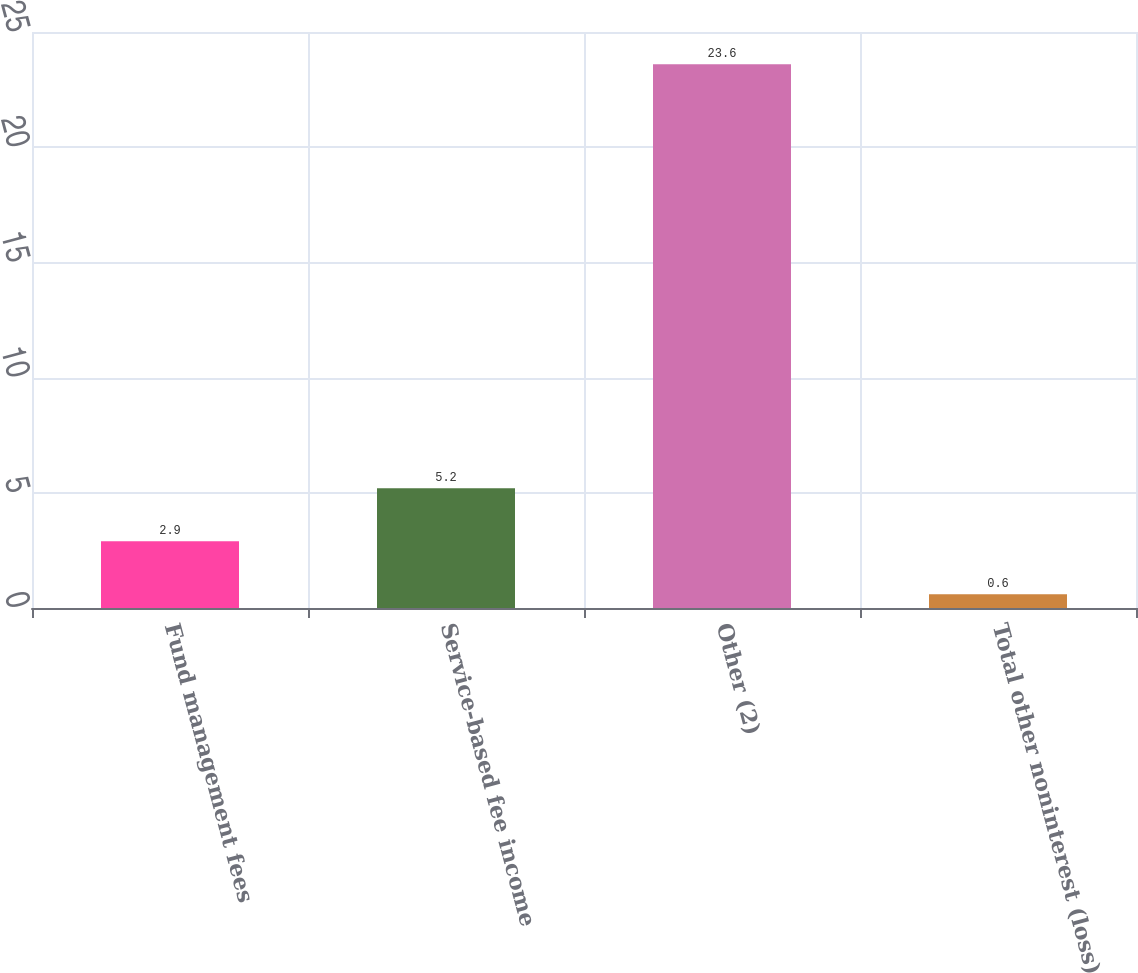<chart> <loc_0><loc_0><loc_500><loc_500><bar_chart><fcel>Fund management fees<fcel>Service-based fee income<fcel>Other (2)<fcel>Total other noninterest (loss)<nl><fcel>2.9<fcel>5.2<fcel>23.6<fcel>0.6<nl></chart> 